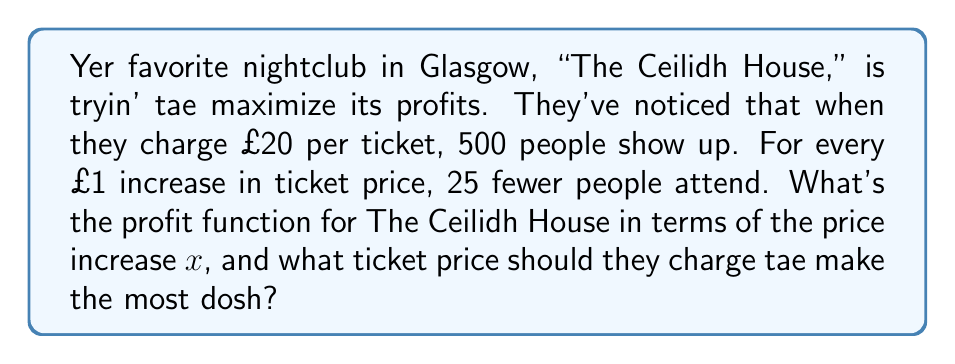Could you help me with this problem? Let's break this down, step by step:

1) First, we need tae express the number of attendees in terms of $x$:
   Attendees = $500 - 25x$, where $x$ is the price increase from £20

2) Now, let's express the ticket price in terms of $x$:
   Price = $20 + x$

3) The revenue is the product of price and attendees:
   Revenue = $(20 + x)(500 - 25x)$

4) Expand this:
   Revenue = $10000 + 500x - 500x - 25x^2 = 10000 - 25x^2$

5) The club has fixed costs (rent, staff, etc.) Let's say these are £5000 per night.

6) Profit is revenue minus fixed costs:
   Profit = $10000 - 25x^2 - 5000 = 5000 - 25x^2$

7) So the profit function is:
   $P(x) = 5000 - 25x^2$

8) To find the maximum profit, we need tae find the vertex of this parabola.
   For a quadratic function $ax^2 + bx + c$, the x-coordinate of the vertex is $-b/(2a)$

9) In our case, $a = -25$, $b = 0$, so:
   $x = -0 / (2(-25)) = 0$

10) This means the profit is maximized when $x = 0$, i.e., when the price increase is £0

11) The optimal ticket price is therefore the original £20
Answer: The profit function is $P(x) = 5000 - 25x^2$, where $x$ is the price increase from £20. The optimal ticket price is £20. 